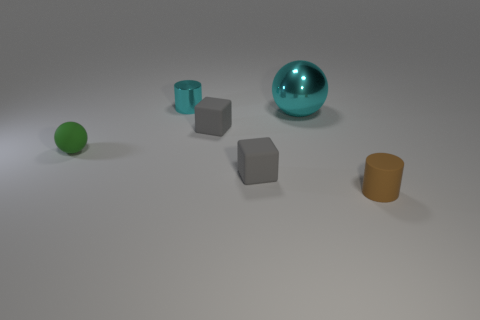What is the size of the shiny object that is the same color as the tiny metallic cylinder?
Provide a short and direct response. Large. Are there fewer cyan shiny balls that are on the left side of the tiny cyan metal thing than small green objects?
Provide a short and direct response. Yes. What color is the tiny thing that is both on the left side of the matte cylinder and in front of the tiny green matte thing?
Your answer should be compact. Gray. What number of other things are the same shape as the big thing?
Give a very brief answer. 1. Is the number of small cyan metallic objects that are to the right of the brown object less than the number of small brown rubber objects behind the big thing?
Your answer should be very brief. No. Is the material of the large object the same as the tiny cylinder in front of the metal ball?
Offer a very short reply. No. Is there anything else that is made of the same material as the big cyan thing?
Make the answer very short. Yes. Is the number of blocks greater than the number of objects?
Provide a short and direct response. No. What shape is the small object behind the metal object in front of the cyan object behind the large sphere?
Give a very brief answer. Cylinder. Does the tiny object behind the large cyan metal sphere have the same material as the gray thing that is in front of the small green thing?
Give a very brief answer. No. 